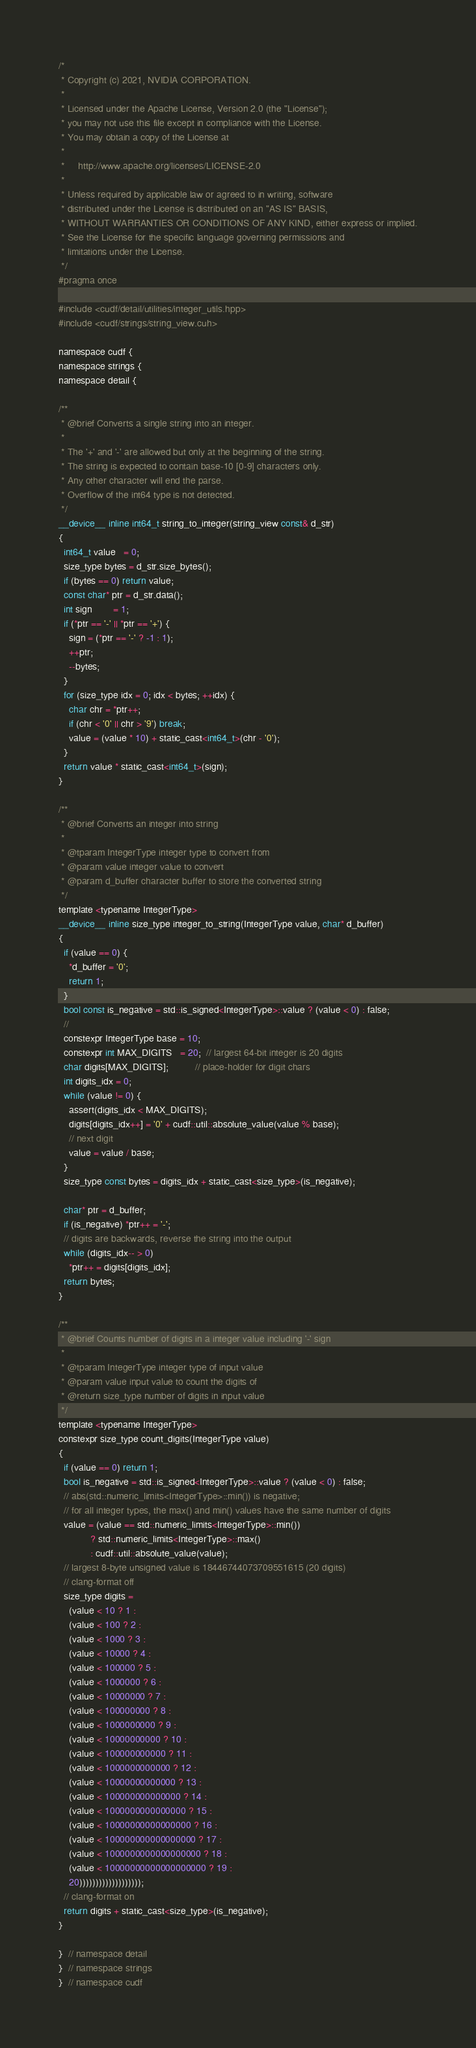Convert code to text. <code><loc_0><loc_0><loc_500><loc_500><_Cuda_>/*
 * Copyright (c) 2021, NVIDIA CORPORATION.
 *
 * Licensed under the Apache License, Version 2.0 (the "License");
 * you may not use this file except in compliance with the License.
 * You may obtain a copy of the License at
 *
 *     http://www.apache.org/licenses/LICENSE-2.0
 *
 * Unless required by applicable law or agreed to in writing, software
 * distributed under the License is distributed on an "AS IS" BASIS,
 * WITHOUT WARRANTIES OR CONDITIONS OF ANY KIND, either express or implied.
 * See the License for the specific language governing permissions and
 * limitations under the License.
 */
#pragma once

#include <cudf/detail/utilities/integer_utils.hpp>
#include <cudf/strings/string_view.cuh>

namespace cudf {
namespace strings {
namespace detail {

/**
 * @brief Converts a single string into an integer.
 *
 * The '+' and '-' are allowed but only at the beginning of the string.
 * The string is expected to contain base-10 [0-9] characters only.
 * Any other character will end the parse.
 * Overflow of the int64 type is not detected.
 */
__device__ inline int64_t string_to_integer(string_view const& d_str)
{
  int64_t value   = 0;
  size_type bytes = d_str.size_bytes();
  if (bytes == 0) return value;
  const char* ptr = d_str.data();
  int sign        = 1;
  if (*ptr == '-' || *ptr == '+') {
    sign = (*ptr == '-' ? -1 : 1);
    ++ptr;
    --bytes;
  }
  for (size_type idx = 0; idx < bytes; ++idx) {
    char chr = *ptr++;
    if (chr < '0' || chr > '9') break;
    value = (value * 10) + static_cast<int64_t>(chr - '0');
  }
  return value * static_cast<int64_t>(sign);
}

/**
 * @brief Converts an integer into string
 *
 * @tparam IntegerType integer type to convert from
 * @param value integer value to convert
 * @param d_buffer character buffer to store the converted string
 */
template <typename IntegerType>
__device__ inline size_type integer_to_string(IntegerType value, char* d_buffer)
{
  if (value == 0) {
    *d_buffer = '0';
    return 1;
  }
  bool const is_negative = std::is_signed<IntegerType>::value ? (value < 0) : false;
  //
  constexpr IntegerType base = 10;
  constexpr int MAX_DIGITS   = 20;  // largest 64-bit integer is 20 digits
  char digits[MAX_DIGITS];          // place-holder for digit chars
  int digits_idx = 0;
  while (value != 0) {
    assert(digits_idx < MAX_DIGITS);
    digits[digits_idx++] = '0' + cudf::util::absolute_value(value % base);
    // next digit
    value = value / base;
  }
  size_type const bytes = digits_idx + static_cast<size_type>(is_negative);

  char* ptr = d_buffer;
  if (is_negative) *ptr++ = '-';
  // digits are backwards, reverse the string into the output
  while (digits_idx-- > 0)
    *ptr++ = digits[digits_idx];
  return bytes;
}

/**
 * @brief Counts number of digits in a integer value including '-' sign
 *
 * @tparam IntegerType integer type of input value
 * @param value input value to count the digits of
 * @return size_type number of digits in input value
 */
template <typename IntegerType>
constexpr size_type count_digits(IntegerType value)
{
  if (value == 0) return 1;
  bool is_negative = std::is_signed<IntegerType>::value ? (value < 0) : false;
  // abs(std::numeric_limits<IntegerType>::min()) is negative;
  // for all integer types, the max() and min() values have the same number of digits
  value = (value == std::numeric_limits<IntegerType>::min())
            ? std::numeric_limits<IntegerType>::max()
            : cudf::util::absolute_value(value);
  // largest 8-byte unsigned value is 18446744073709551615 (20 digits)
  // clang-format off
  size_type digits =
    (value < 10 ? 1 :
    (value < 100 ? 2 :
    (value < 1000 ? 3 :
    (value < 10000 ? 4 :
    (value < 100000 ? 5 :
    (value < 1000000 ? 6 :
    (value < 10000000 ? 7 :
    (value < 100000000 ? 8 :
    (value < 1000000000 ? 9 :
    (value < 10000000000 ? 10 :
    (value < 100000000000 ? 11 :
    (value < 1000000000000 ? 12 :
    (value < 10000000000000 ? 13 :
    (value < 100000000000000 ? 14 :
    (value < 1000000000000000 ? 15 :
    (value < 10000000000000000 ? 16 :
    (value < 100000000000000000 ? 17 :
    (value < 1000000000000000000 ? 18 :
    (value < 10000000000000000000 ? 19 :
    20)))))))))))))))))));
  // clang-format on
  return digits + static_cast<size_type>(is_negative);
}

}  // namespace detail
}  // namespace strings
}  // namespace cudf
</code> 